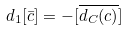<formula> <loc_0><loc_0><loc_500><loc_500>d _ { 1 } [ \bar { c } ] = - [ \overline { d _ { C } ( c ) } ]</formula> 